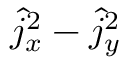<formula> <loc_0><loc_0><loc_500><loc_500>\hat { j } _ { x } ^ { 2 } - \hat { j } _ { y } ^ { 2 }</formula> 